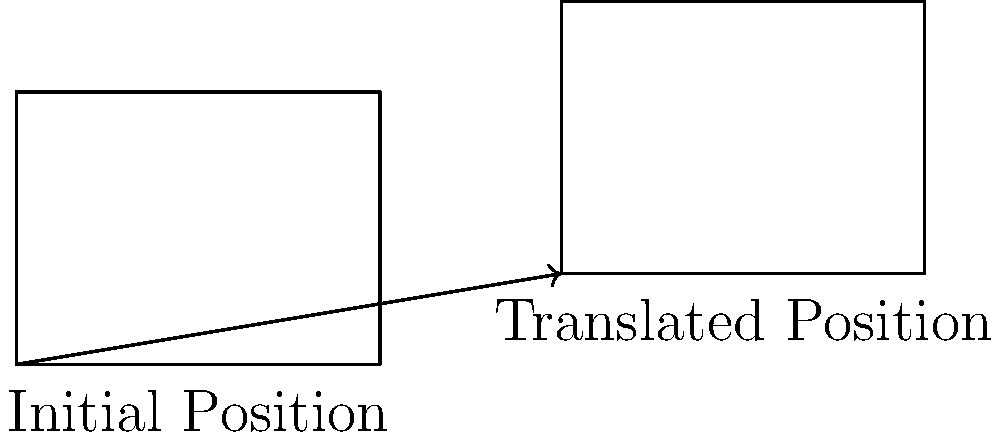A solar farm is planning to relocate its panels to optimize land use. The current position of a solar panel array is represented by a rectangle with coordinates $A(0,0)$, $B(4,0)$, $C(4,3)$, and $D(0,3)$. If the array is translated 6 units right and 1 unit up, what are the coordinates of the translated rectangle's top-left corner? Consider how this relocation might impact the efficiency claims made by solar proponents. To solve this problem, we need to apply the concept of translation in transformational geometry. Here's a step-by-step explanation:

1) The original top-left corner of the rectangle is point D with coordinates (0,3).

2) The translation is 6 units right and 1 unit up. In coordinate geometry, this is represented as a vector (6,1).

3) To find the new coordinates, we add the translation vector to the original coordinates:
   $$(0,3) + (6,1) = (0+6, 3+1) = (6,4)$$

4) Therefore, the new coordinates of the top-left corner are (6,4).

It's worth noting that while this optimization might improve land use efficiency, it doesn't address the fundamental issues of solar energy's reliance on favorable weather conditions and government subsidies. The need for such optimizations could be seen as an admission of the technology's limitations.
Answer: (6,4) 